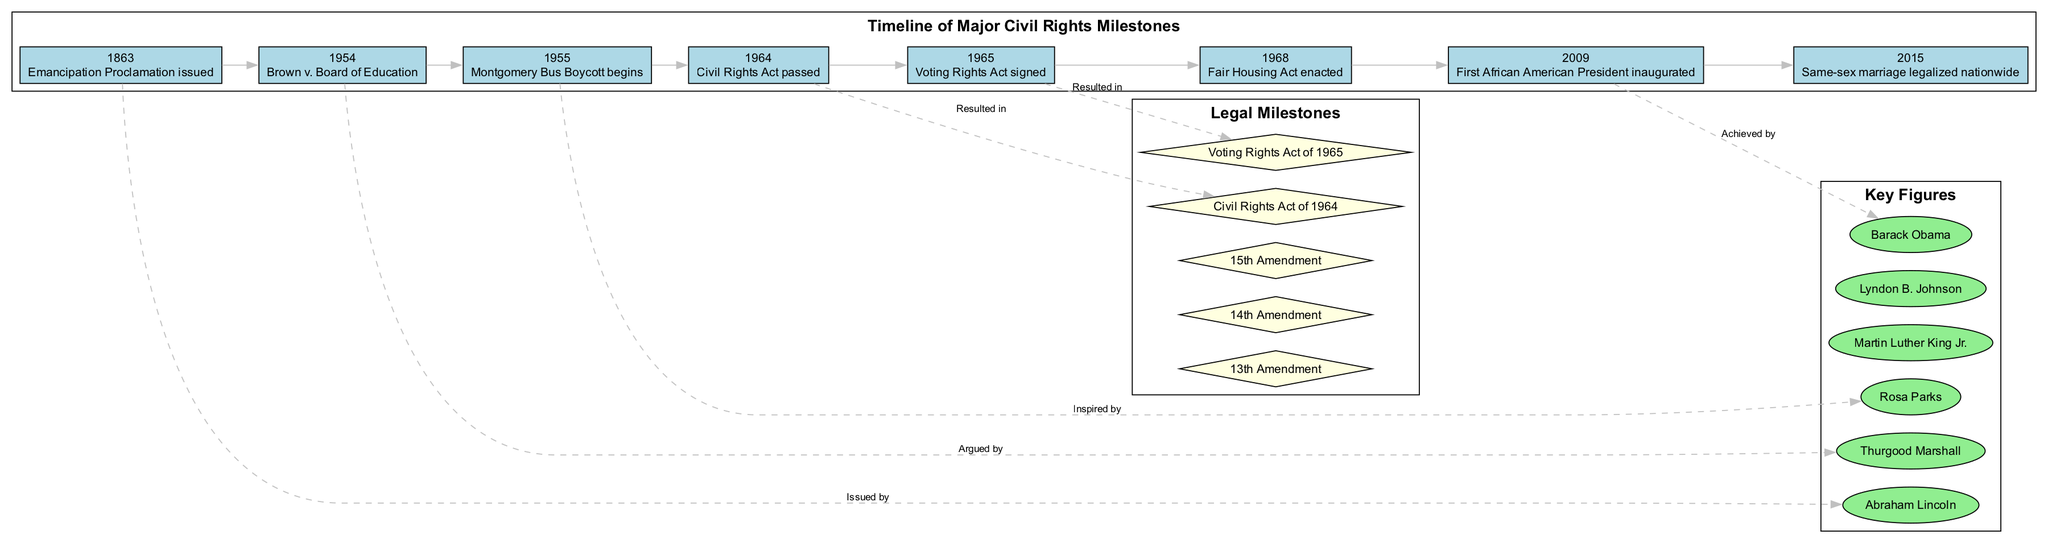What year was the Emancipation Proclamation issued? The diagram indicates that the Emancipation Proclamation was issued in the year 1863, as shown in the node connected to that event.
Answer: 1863 Who argued the case of Brown v. Board of Education? The diagram links the event of Brown v. Board of Education from 1954 to the figure of Thurgood Marshall, showing that he was the one who argued the case.
Answer: Thurgood Marshall What legal milestone corresponds with the year 1968? By looking at the legal milestones section of the diagram, the key milestones are listed and the Fair Housing Act corresponds to the year 1968, as it appears in that cluster.
Answer: Fair Housing Act Which key figure is associated with the event that inspired the Montgomery Bus Boycott? The diagram shows a connection from the Montgomery Bus Boycott in 1955 to the figure of Rosa Parks, indicating that she was a significant inspiration for that event.
Answer: Rosa Parks What are the total number of timeline events shown in the diagram? Count the nodes in the timeline section; there are eight distinct events listed in the timeline of major civil rights milestones, therefore the total is eight.
Answer: 8 What resulted in the Civil Rights Act of 1964? The diagram highlights that the event of the enactment of the Civil Rights Act in 1964 was a result of those prior achievements represented in the timeline, specifically connecting back from the act to the events leading up to it.
Answer: Civil Rights Act of 1964 How many key figures are highlighted in the diagram? In the key figures section, there are six individuals depicted, which can be counted directly from the corresponding nodes in that part of the diagram.
Answer: 6 Which amendment abolished slavery? From the legal milestones section of the diagram, the 13th Amendment is noted as the one that abolished slavery, which can be easily identified by its inclusion in the list provided.
Answer: 13th Amendment 